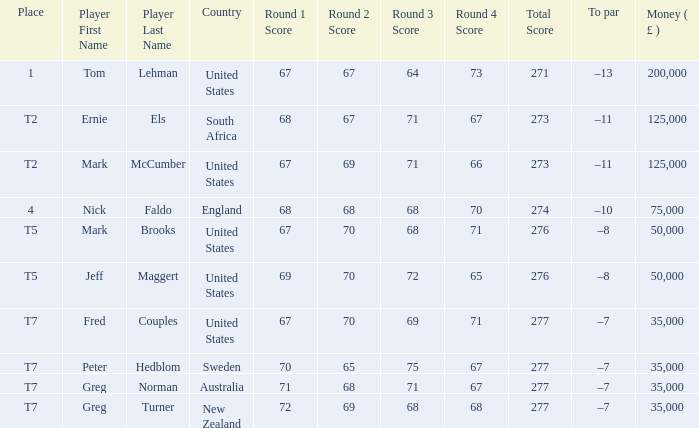What is Score, when Country is "United States", and when Player is "Mark Brooks"? 67-70-68-71=276. Help me parse the entirety of this table. {'header': ['Place', 'Player First Name', 'Player Last Name', 'Country', 'Round 1 Score', 'Round 2 Score', 'Round 3 Score', 'Round 4 Score', 'Total Score', 'To par', 'Money ( £ )'], 'rows': [['1', 'Tom', 'Lehman', 'United States', '67', '67', '64', '73', '271', '–13', '200,000'], ['T2', 'Ernie', 'Els', 'South Africa', '68', '67', '71', '67', '273', '–11', '125,000'], ['T2', 'Mark', 'McCumber', 'United States', '67', '69', '71', '66', '273', '–11', '125,000'], ['4', 'Nick', 'Faldo', 'England', '68', '68', '68', '70', '274', '–10', '75,000'], ['T5', 'Mark', 'Brooks', 'United States', '67', '70', '68', '71', '276', '–8', '50,000'], ['T5', 'Jeff', 'Maggert', 'United States', '69', '70', '72', '65', '276', '–8', '50,000'], ['T7', 'Fred', 'Couples', 'United States', '67', '70', '69', '71', '277', '–7', '35,000'], ['T7', 'Peter', 'Hedblom', 'Sweden', '70', '65', '75', '67', '277', '–7', '35,000'], ['T7', 'Greg', 'Norman', 'Australia', '71', '68', '71', '67', '277', '–7', '35,000'], ['T7', 'Greg', 'Turner', 'New Zealand', '72', '69', '68', '68', '277', '–7', '35,000']]} 